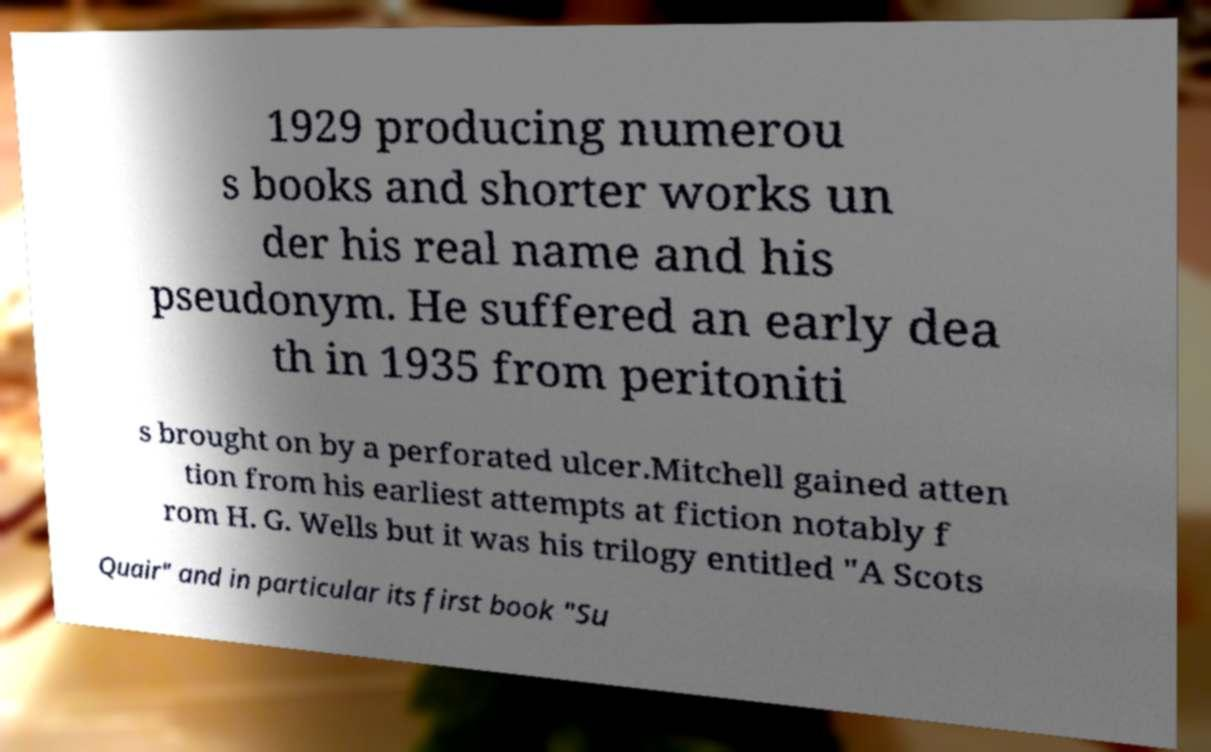What messages or text are displayed in this image? I need them in a readable, typed format. 1929 producing numerou s books and shorter works un der his real name and his pseudonym. He suffered an early dea th in 1935 from peritoniti s brought on by a perforated ulcer.Mitchell gained atten tion from his earliest attempts at fiction notably f rom H. G. Wells but it was his trilogy entitled "A Scots Quair" and in particular its first book "Su 